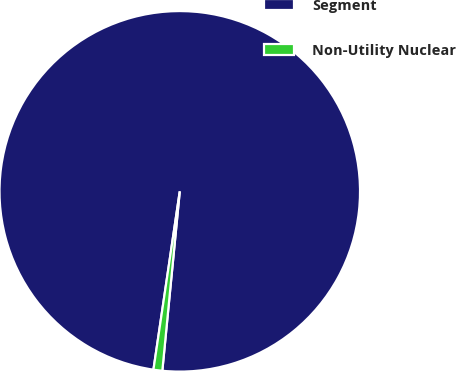Convert chart. <chart><loc_0><loc_0><loc_500><loc_500><pie_chart><fcel>Segment<fcel>Non-Utility Nuclear<nl><fcel>99.21%<fcel>0.79%<nl></chart> 